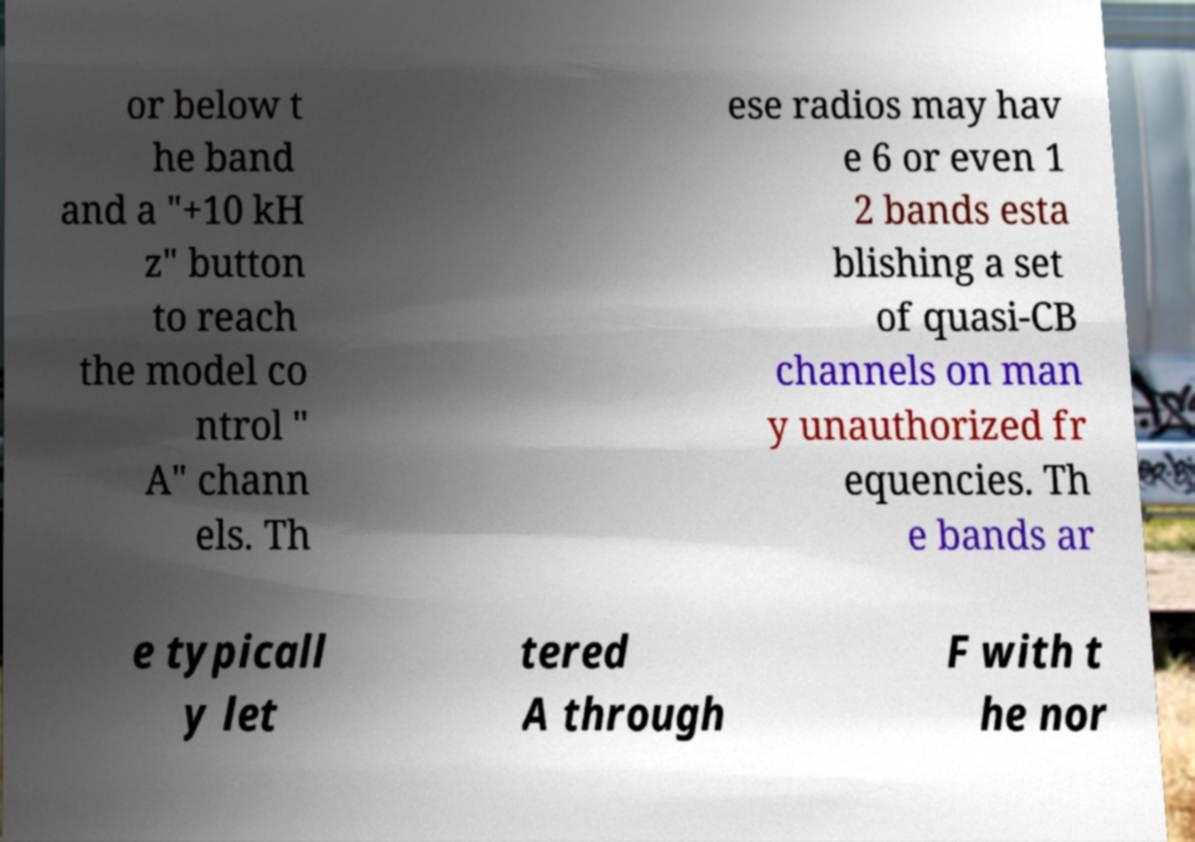Can you read and provide the text displayed in the image?This photo seems to have some interesting text. Can you extract and type it out for me? or below t he band and a "+10 kH z" button to reach the model co ntrol " A" chann els. Th ese radios may hav e 6 or even 1 2 bands esta blishing a set of quasi-CB channels on man y unauthorized fr equencies. Th e bands ar e typicall y let tered A through F with t he nor 